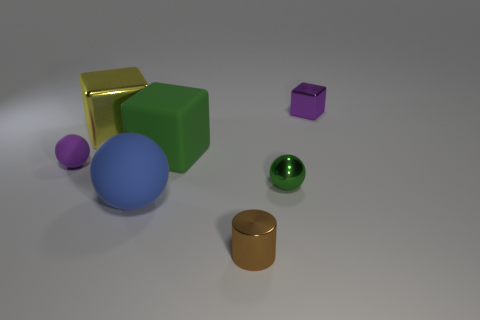Add 1 metallic spheres. How many objects exist? 8 Subtract all tiny shiny cubes. How many cubes are left? 2 Subtract all green blocks. How many blocks are left? 2 Subtract all spheres. How many objects are left? 4 Subtract all red cylinders. How many yellow blocks are left? 1 Subtract all green objects. Subtract all big brown metal things. How many objects are left? 5 Add 7 big metallic things. How many big metallic things are left? 8 Add 5 brown shiny things. How many brown shiny things exist? 6 Subtract 0 brown balls. How many objects are left? 7 Subtract 1 cubes. How many cubes are left? 2 